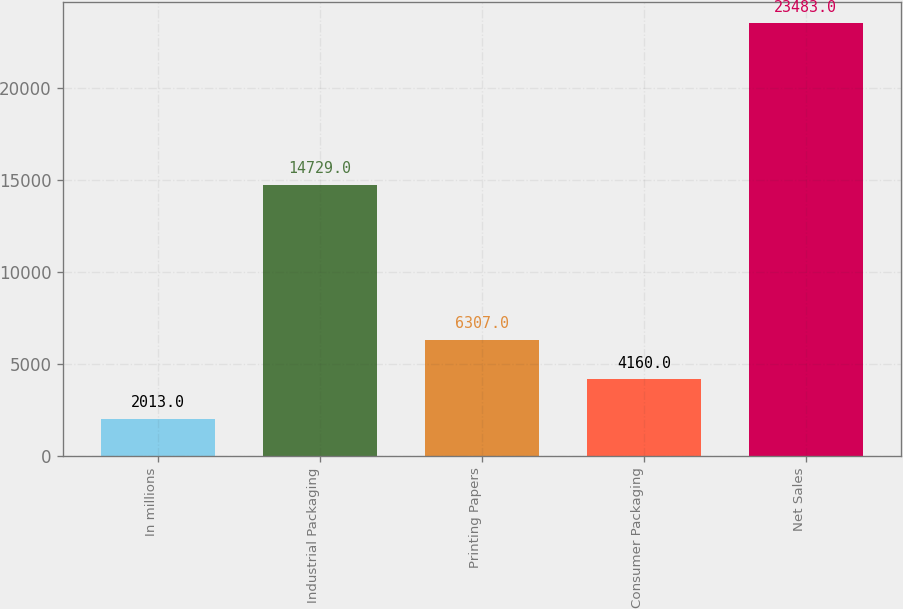<chart> <loc_0><loc_0><loc_500><loc_500><bar_chart><fcel>In millions<fcel>Industrial Packaging<fcel>Printing Papers<fcel>Consumer Packaging<fcel>Net Sales<nl><fcel>2013<fcel>14729<fcel>6307<fcel>4160<fcel>23483<nl></chart> 